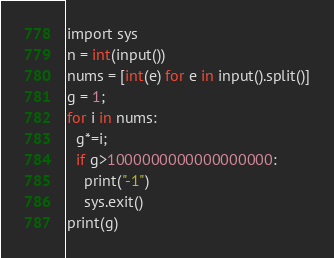<code> <loc_0><loc_0><loc_500><loc_500><_C#_>import sys
n = int(input())
nums = [int(e) for e in input().split()]
g = 1;
for i in nums:
  g*=i;
  if g>1000000000000000000:
    print("-1")
    sys.exit()
print(g)
</code> 